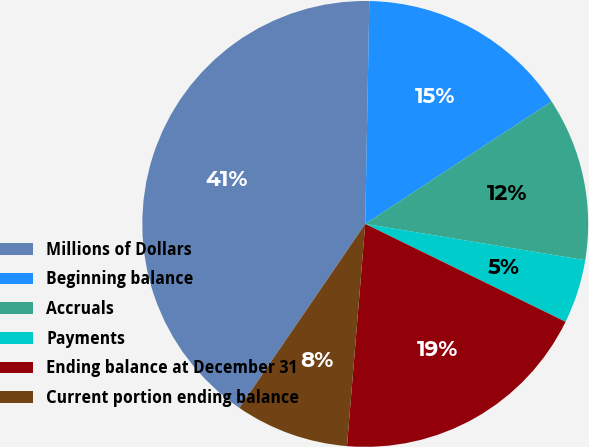Convert chart. <chart><loc_0><loc_0><loc_500><loc_500><pie_chart><fcel>Millions of Dollars<fcel>Beginning balance<fcel>Accruals<fcel>Payments<fcel>Ending balance at December 31<fcel>Current portion ending balance<nl><fcel>40.74%<fcel>15.46%<fcel>11.85%<fcel>4.63%<fcel>19.07%<fcel>8.24%<nl></chart> 